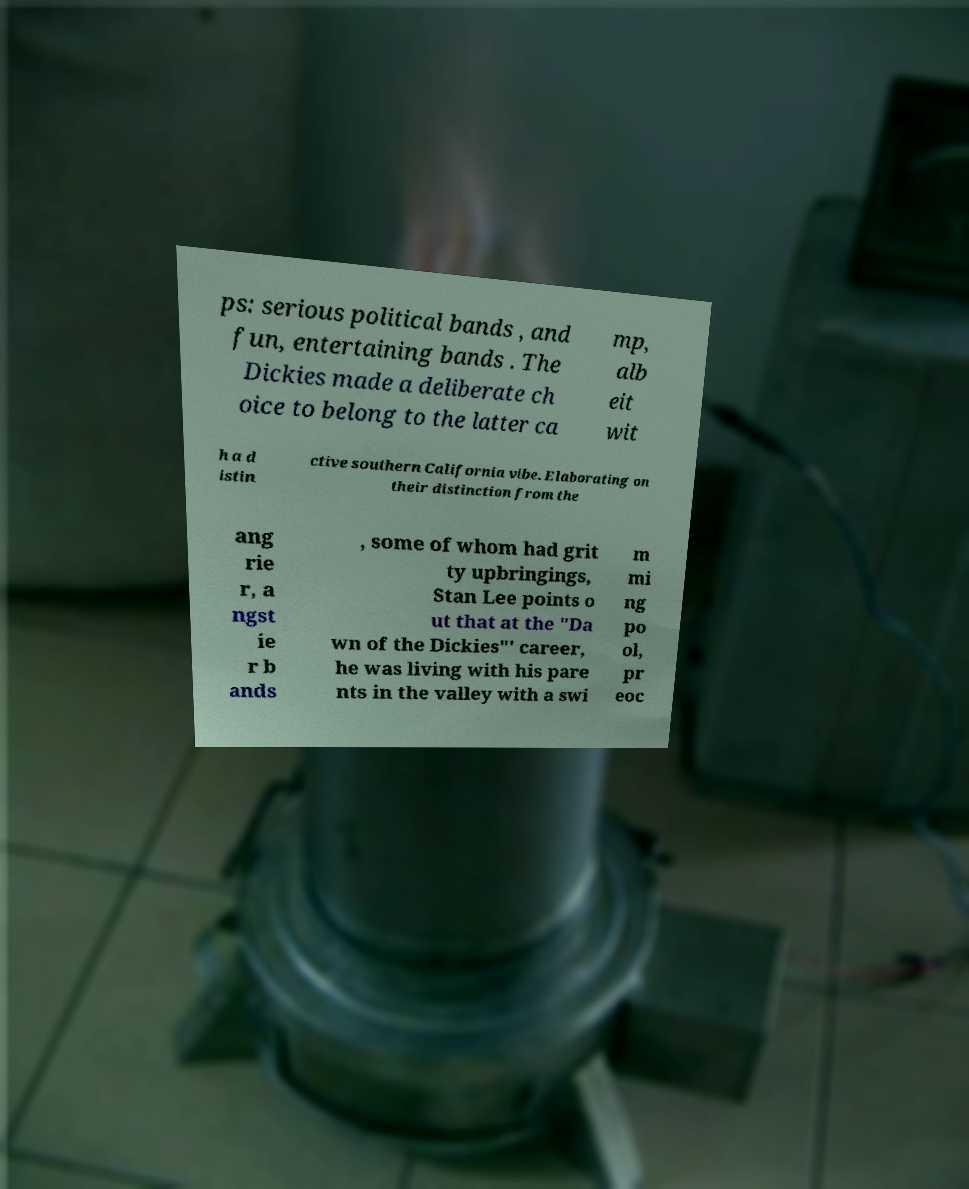Can you read and provide the text displayed in the image?This photo seems to have some interesting text. Can you extract and type it out for me? ps: serious political bands , and fun, entertaining bands . The Dickies made a deliberate ch oice to belong to the latter ca mp, alb eit wit h a d istin ctive southern California vibe. Elaborating on their distinction from the ang rie r, a ngst ie r b ands , some of whom had grit ty upbringings, Stan Lee points o ut that at the "Da wn of the Dickies"' career, he was living with his pare nts in the valley with a swi m mi ng po ol, pr eoc 